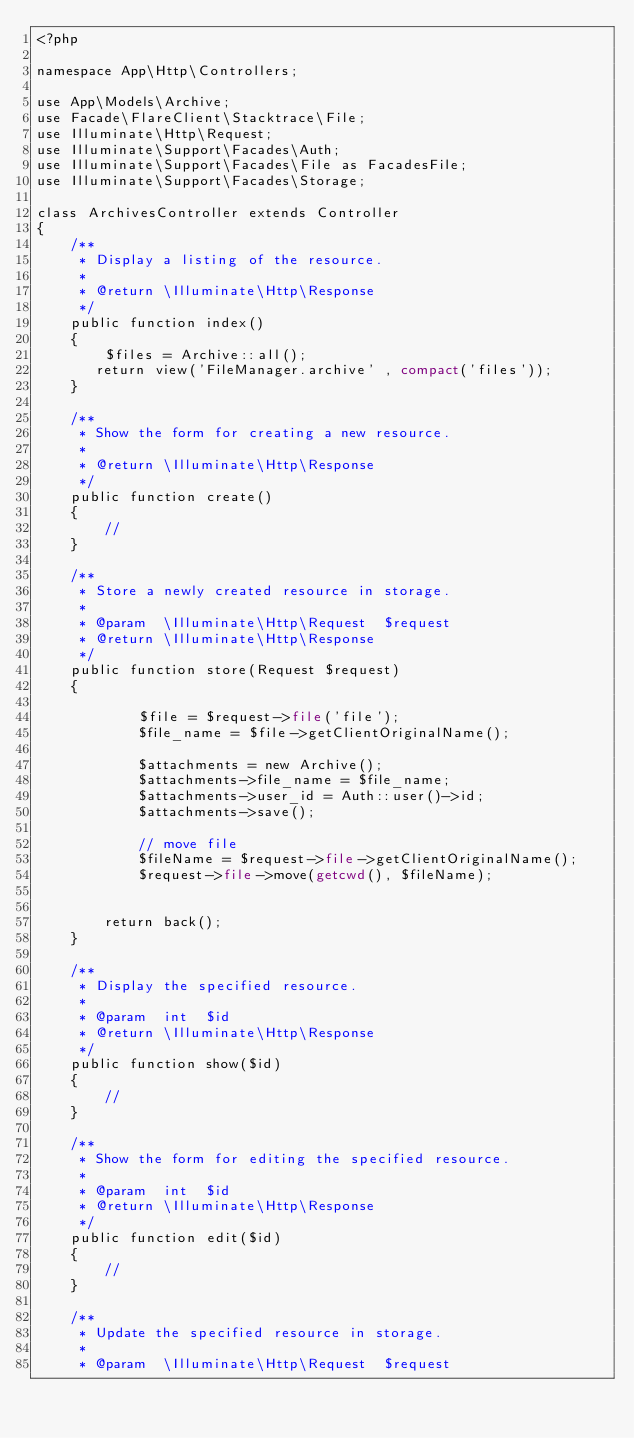<code> <loc_0><loc_0><loc_500><loc_500><_PHP_><?php

namespace App\Http\Controllers;

use App\Models\Archive;
use Facade\FlareClient\Stacktrace\File;
use Illuminate\Http\Request;
use Illuminate\Support\Facades\Auth;
use Illuminate\Support\Facades\File as FacadesFile;
use Illuminate\Support\Facades\Storage;

class ArchivesController extends Controller
{
    /**
     * Display a listing of the resource.
     *
     * @return \Illuminate\Http\Response
     */
    public function index()
    {
        $files = Archive::all();
       return view('FileManager.archive' , compact('files'));
    }

    /**
     * Show the form for creating a new resource.
     *
     * @return \Illuminate\Http\Response
     */
    public function create()
    {
        //
    }

    /**
     * Store a newly created resource in storage.
     *
     * @param  \Illuminate\Http\Request  $request
     * @return \Illuminate\Http\Response
     */
    public function store(Request $request)
    {

            $file = $request->file('file');
            $file_name = $file->getClientOriginalName();

            $attachments = new Archive();
            $attachments->file_name = $file_name;
            $attachments->user_id = Auth::user()->id;
            $attachments->save();

            // move file
            $fileName = $request->file->getClientOriginalName();
            $request->file->move(getcwd(), $fileName);


        return back();
    }

    /**
     * Display the specified resource.
     *
     * @param  int  $id
     * @return \Illuminate\Http\Response
     */
    public function show($id)
    {
        //
    }

    /**
     * Show the form for editing the specified resource.
     *
     * @param  int  $id
     * @return \Illuminate\Http\Response
     */
    public function edit($id)
    {
        //
    }

    /**
     * Update the specified resource in storage.
     *
     * @param  \Illuminate\Http\Request  $request</code> 